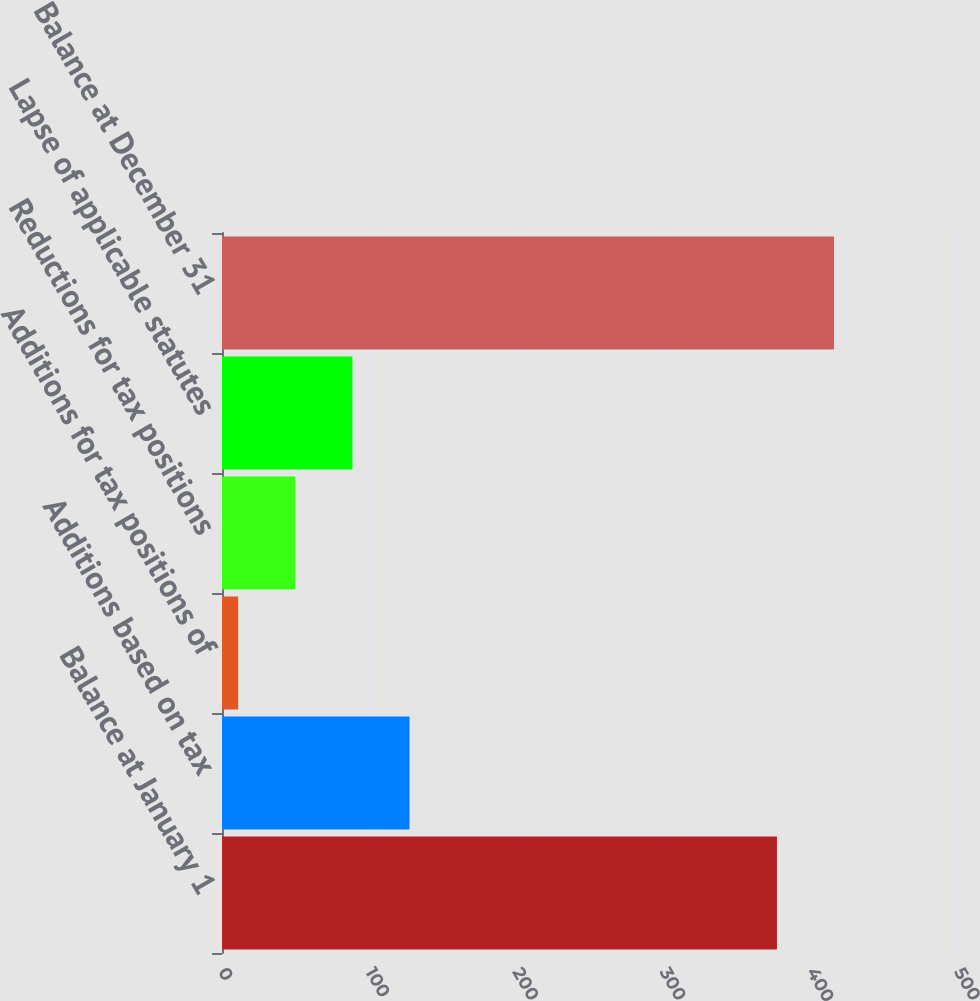Convert chart to OTSL. <chart><loc_0><loc_0><loc_500><loc_500><bar_chart><fcel>Balance at January 1<fcel>Additions based on tax<fcel>Additions for tax positions of<fcel>Reductions for tax positions<fcel>Lapse of applicable statutes<fcel>Balance at December 31<nl><fcel>377<fcel>127.4<fcel>11<fcel>49.8<fcel>88.6<fcel>415.8<nl></chart> 